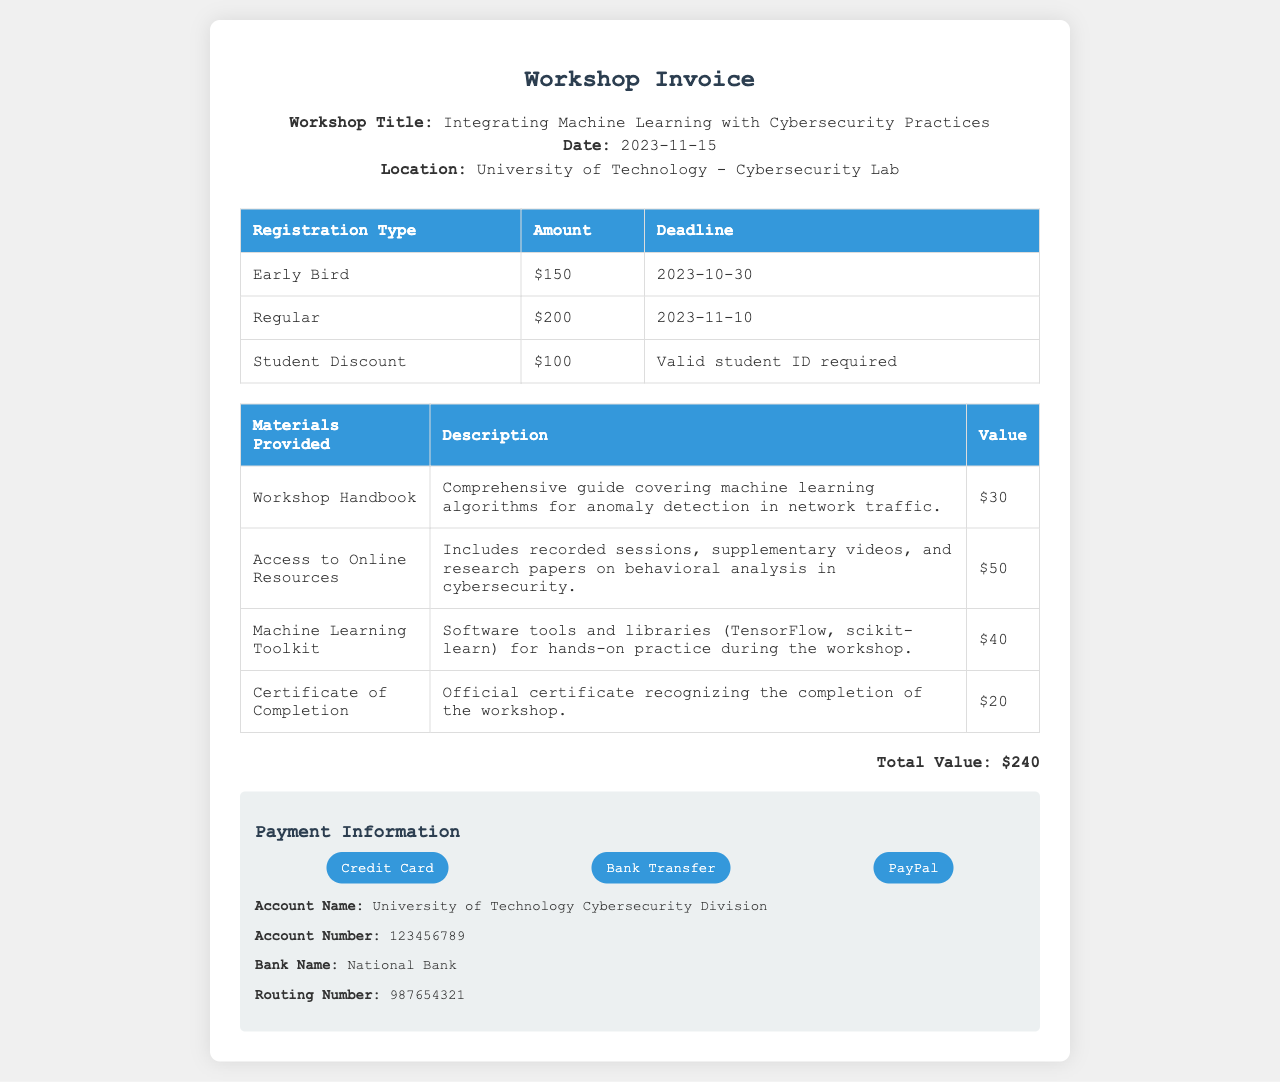What is the title of the workshop? The title of the workshop is mentioned prominently in the header section of the document.
Answer: Integrating Machine Learning with Cybersecurity Practices What is the date of the workshop? The date is explicitly stated in the header of the document.
Answer: 2023-11-15 What is the early bird registration fee? The amount for the early bird registration type is listed in the registration table.
Answer: $150 What materials are provided for the workshop? A table in the document lists the materials provided during the workshop.
Answer: Workshop Handbook, Access to Online Resources, Machine Learning Toolkit, Certificate of Completion What is the total value of the workshop? The total value is calculated and displayed at the bottom of the document.
Answer: $240 What types of payment methods are accepted? The document lists three methods for payment in the payment information section.
Answer: Credit Card, Bank Transfer, PayPal What discount is available for students? The document provides a registration detail specifically for students.
Answer: $100 What is the deadline for regular registration? The deadline is mentioned next to the regular registration fee in the table.
Answer: 2023-11-10 What is included in the access to online resources? The description in the materials table specifies what is included.
Answer: Recorded sessions, supplementary videos, and research papers on behavioral analysis in cybersecurity 